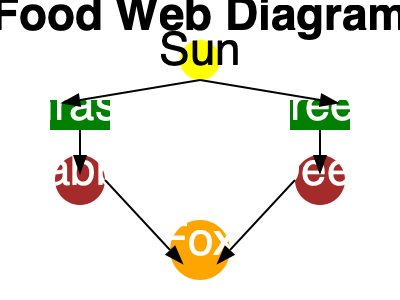In the food web diagram, if the rabbit population suddenly decreases due to a disease, how would this affect the fox population? Explain the potential short-term and long-term impacts on the ecosystem. To understand the impact of a decrease in the rabbit population on the fox and the ecosystem, let's follow these steps:

1. Immediate effect on foxes:
   - Foxes rely on rabbits as a food source.
   - A decrease in rabbit population means less available food for foxes.

2. Short-term impacts:
   - Foxes may face food scarcity, leading to:
     a) Increased competition among foxes for remaining rabbits.
     b) Possible decline in fox population due to malnutrition or starvation.

3. Adaptation of foxes:
   - Foxes may shift their diet to rely more on deer.
   - This demonstrates the interconnectedness of species in the ecosystem.

4. Impact on deer population:
   - Increased predation on deer by foxes may lead to a decrease in deer population.

5. Impact on vegetation:
   - Short-term: Decrease in rabbit population may lead to an increase in grass.
   - Long-term: If deer population decreases, tree saplings may have a better chance of survival.

6. Ecosystem balance:
   - The food web will try to reach a new equilibrium.
   - This showcases the concept of ecological resilience.

7. Long-term impacts:
   - If rabbit population recovers:
     a) Fox population may rebound.
     b) Pressure on deer population may decrease.
   - If rabbit population doesn't recover:
     a) Fox population may remain low or adapt to new food sources.
     b) This could lead to changes in the entire ecosystem structure.

8. Interconnectedness:
   - This scenario demonstrates how a change in one population can have ripple effects throughout the ecosystem, affecting multiple species and their relationships.
Answer: Decrease in fox population short-term; potential long-term ecosystem restructuring 